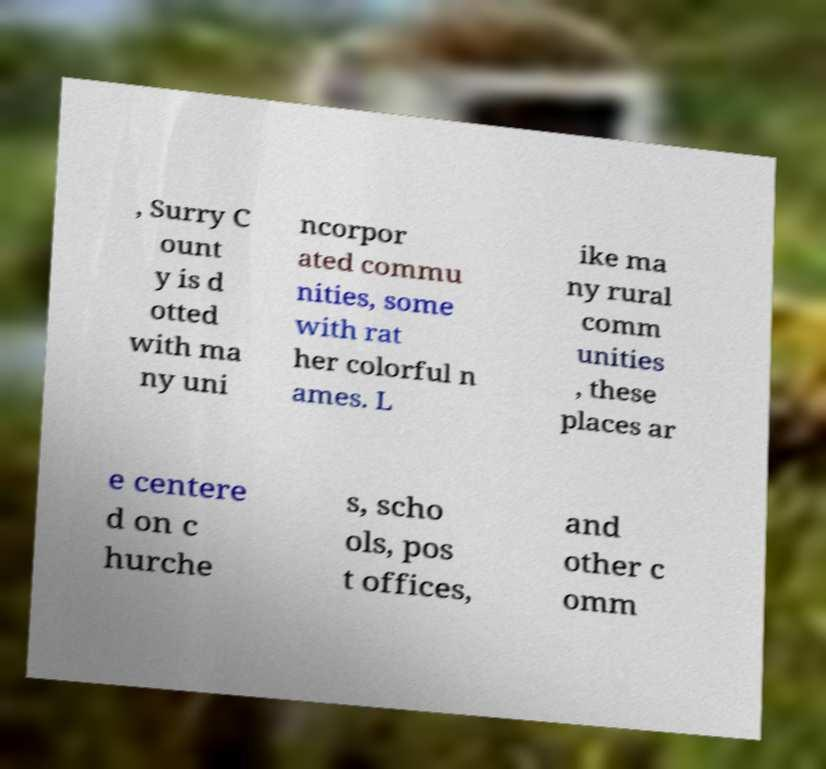What messages or text are displayed in this image? I need them in a readable, typed format. , Surry C ount y is d otted with ma ny uni ncorpor ated commu nities, some with rat her colorful n ames. L ike ma ny rural comm unities , these places ar e centere d on c hurche s, scho ols, pos t offices, and other c omm 